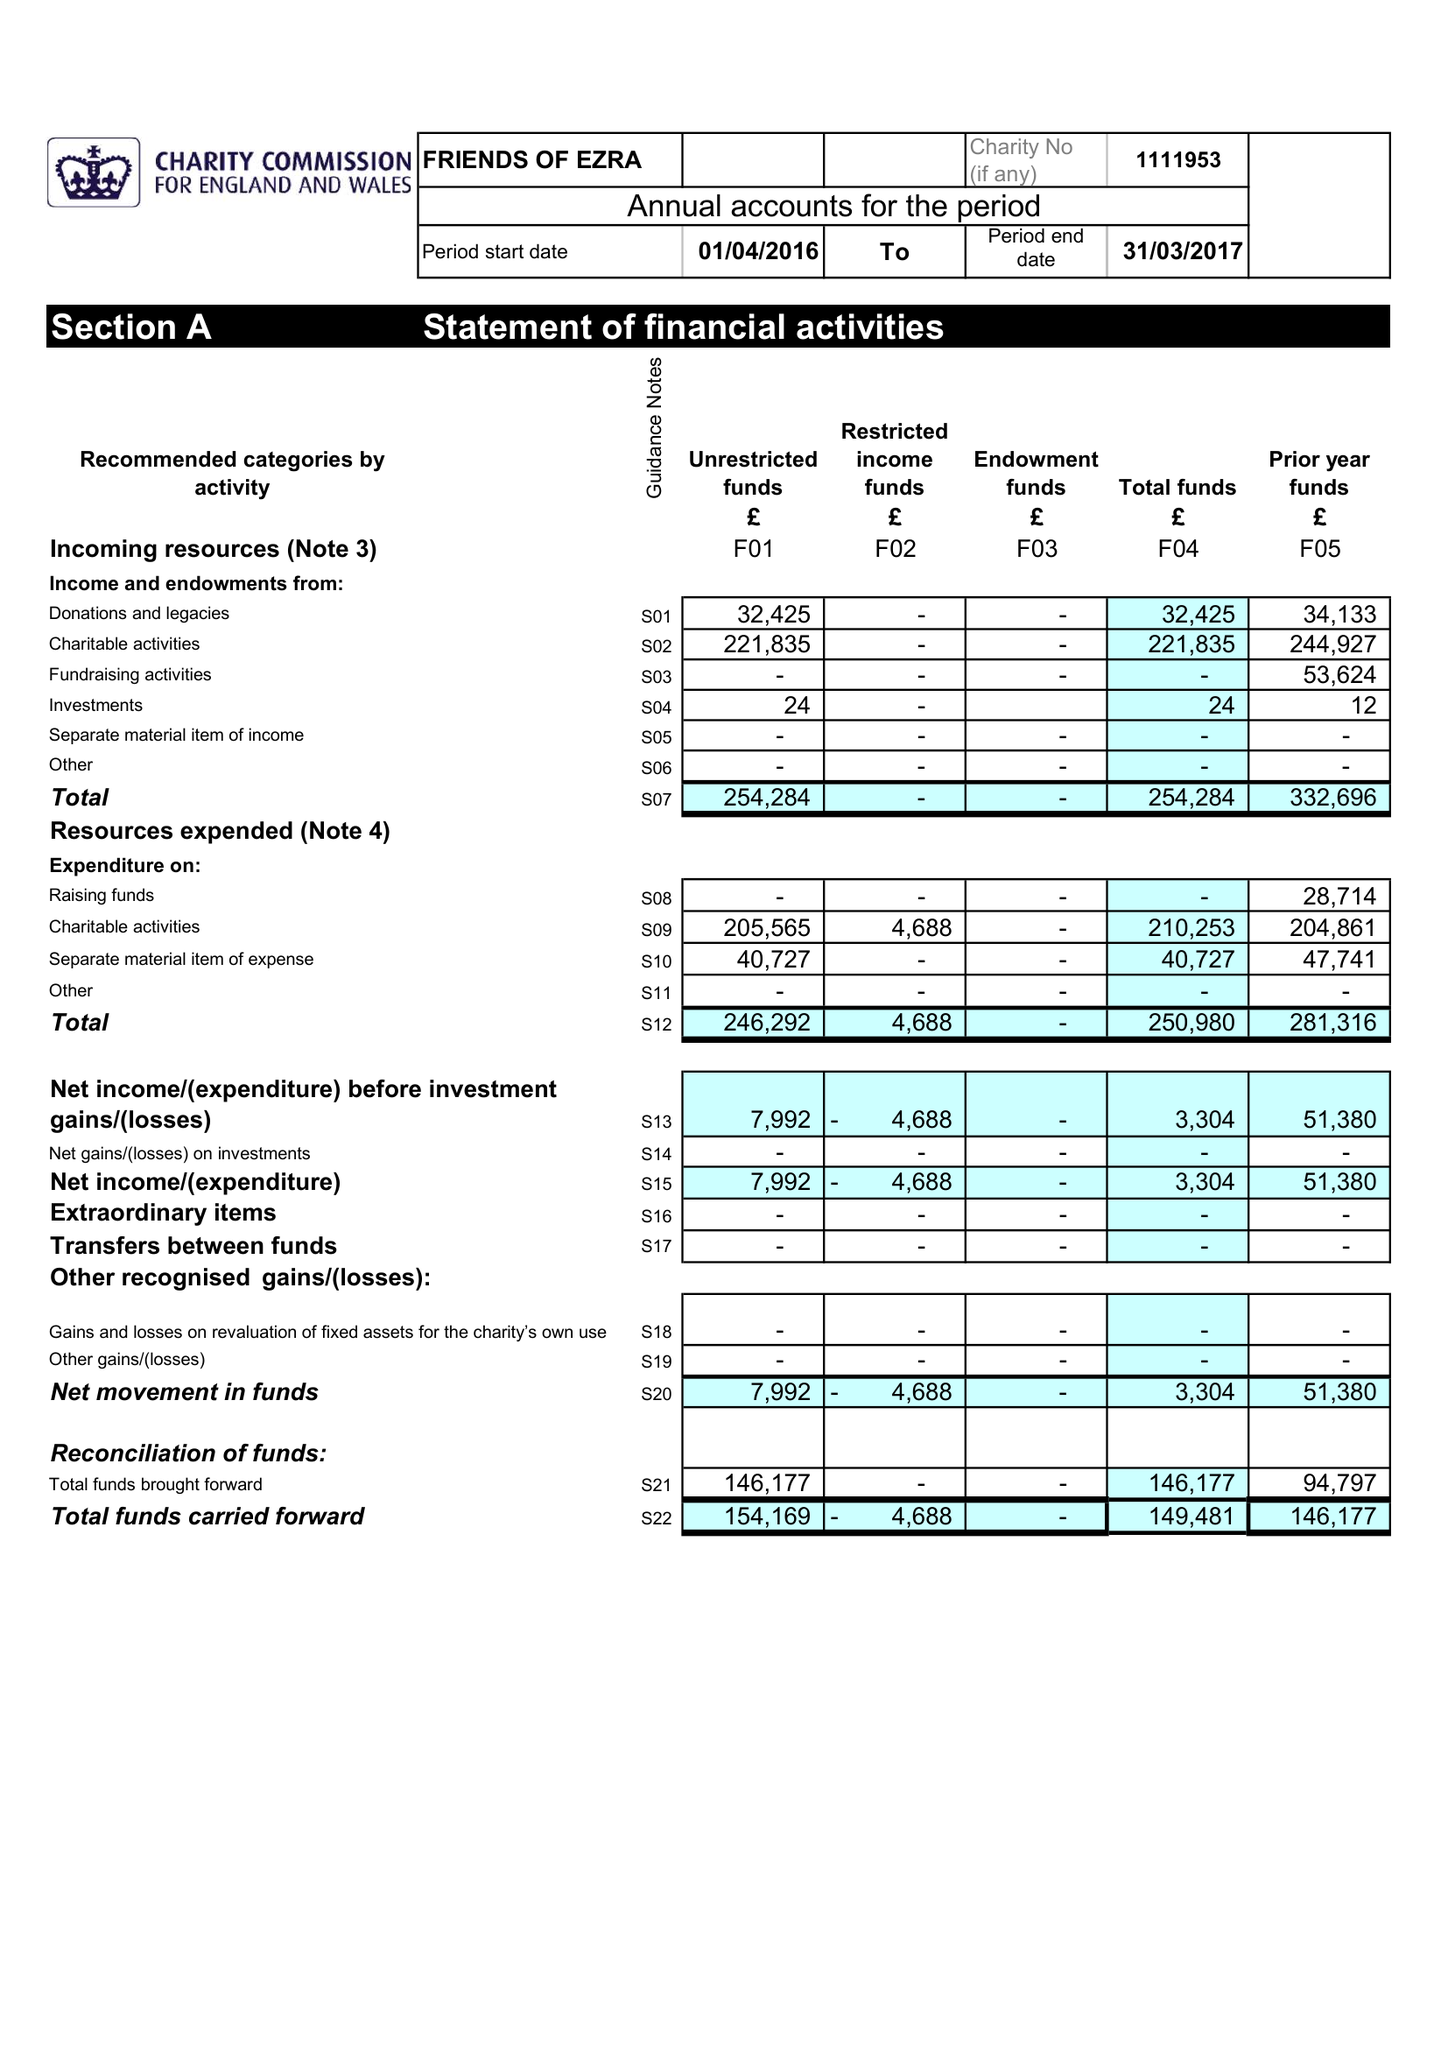What is the value for the charity_number?
Answer the question using a single word or phrase. 1111593 